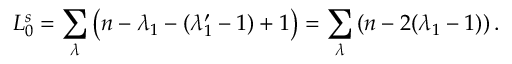Convert formula to latex. <formula><loc_0><loc_0><loc_500><loc_500>L _ { 0 } ^ { s } = \sum _ { \lambda } \left ( n - \lambda _ { 1 } - ( \lambda _ { 1 } ^ { \prime } - 1 ) + 1 \right ) = \sum _ { \lambda } \left ( n - 2 ( \lambda _ { 1 } - 1 ) \right .</formula> 